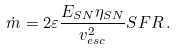Convert formula to latex. <formula><loc_0><loc_0><loc_500><loc_500>\dot { m } = 2 \varepsilon \frac { E _ { S N } \eta _ { S N } } { v _ { e s c } ^ { 2 } } S F R \, .</formula> 